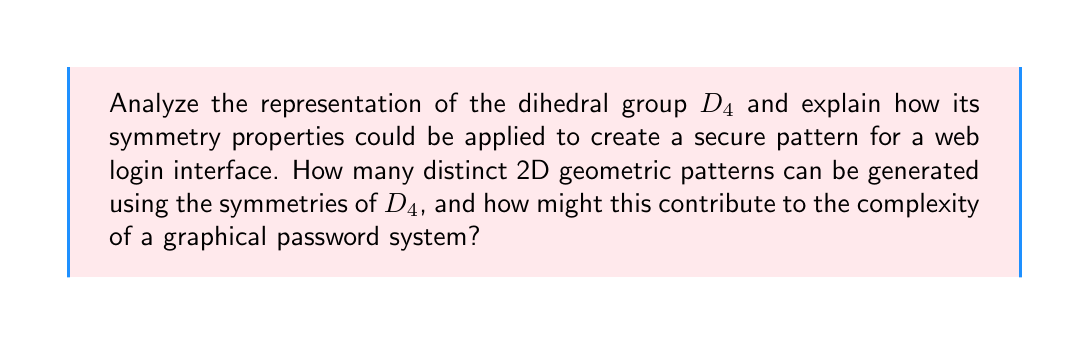Provide a solution to this math problem. To answer this question, let's break it down into steps:

1. Understanding $D_4$:
   The dihedral group $D_4$ represents the symmetries of a square. It has 8 elements:
   - 4 rotations: 0°, 90°, 180°, 270°
   - 4 reflections: 2 diagonal, 2 axial (vertical and horizontal)

2. Representation of $D_4$:
   $D_4$ can be represented as a group of 2x2 matrices. For example:
   - Rotation by 90°: $$R_{90} = \begin{pmatrix} 0 & -1 \\ 1 & 0 \end{pmatrix}$$
   - Reflection about y-axis: $$F_y = \begin{pmatrix} -1 & 0 \\ 0 & 1 \end{pmatrix}$$

3. Applying $D_4$ to web design:
   We can use these transformations to create patterns on a 2D grid, which could form the basis of a graphical password system.

4. Generating distinct patterns:
   To count the number of distinct patterns, we need to consider:
   - The number of possible starting configurations
   - The number of symmetry operations

   Let's assume we're using a 4x4 grid where each cell can be either filled or empty.

5. Calculating distinct patterns:
   - Total possible patterns on a 4x4 grid: $2^{16} = 65,536$
   - However, many of these are equivalent under $D_4$ symmetries
   - The number of distinct patterns is:
     $$(2^{16} + 2^6 + 3 \cdot 2^4) / 8 = 8,330$$

   This formula accounts for patterns invariant under certain symmetries.

6. Security implications:
   - 8,330 distinct patterns provide a reasonable level of complexity
   - This is comparable to a 4-digit PIN (10,000 possibilities)
   - The visual nature may be more memorable than a numeric code

7. Implementation in web design:
   - Users could draw a pattern on a 4x4 grid for login
   - The system would store the pattern's equivalence class under $D_4$
   - This allows for some variation in user input while maintaining security

8. Additional security layer:
   - The system could randomly apply a $D_4$ transformation to the displayed grid
   - This would require users to mentally apply the inverse transformation
   - This adds a dynamic element, increasing security against shoulder-surfing
Answer: 8,330 distinct patterns; enhances graphical password complexity and memorability while allowing input variation. 